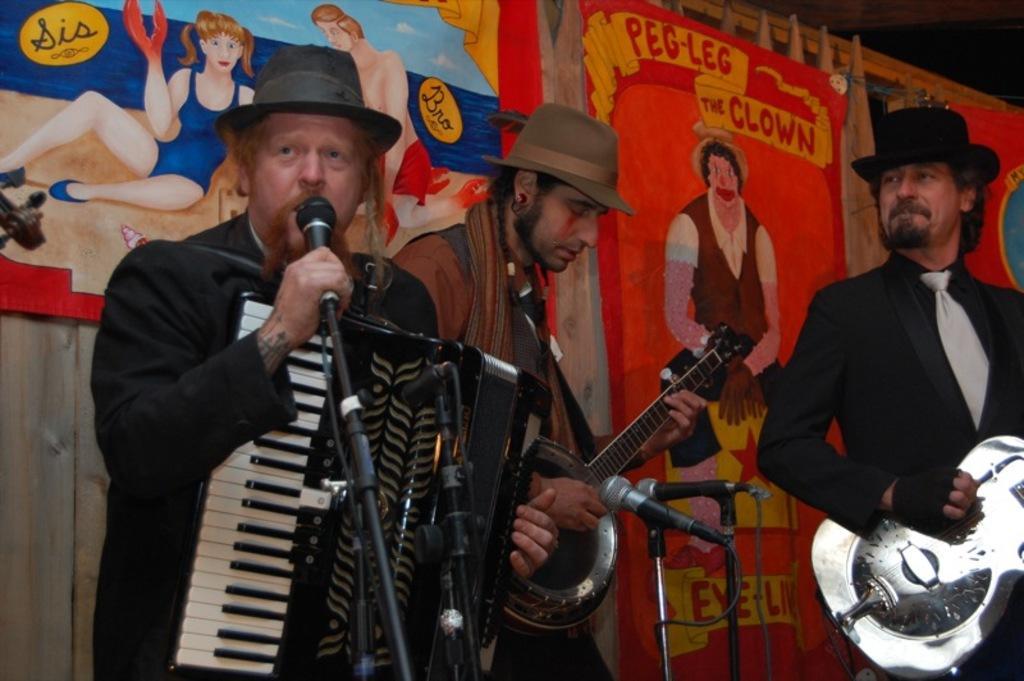Could you give a brief overview of what you see in this image? In this image there are three people playing musical instruments, in front of them there are mice, behind them there are banner with some images are hanging on the wooden wall. 